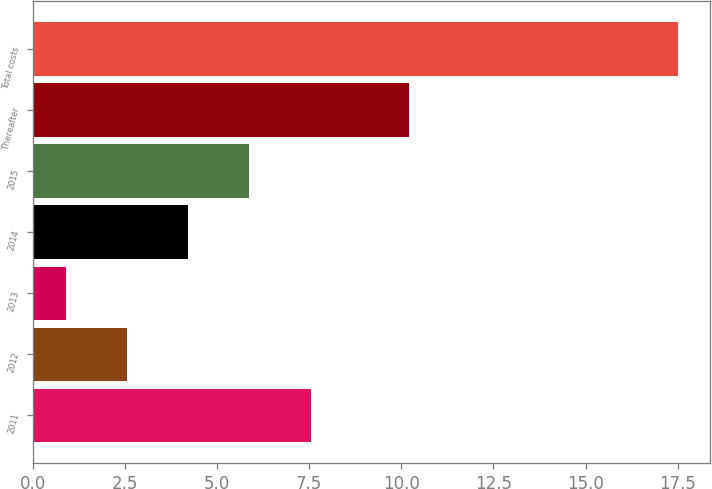<chart> <loc_0><loc_0><loc_500><loc_500><bar_chart><fcel>2011<fcel>2012<fcel>2013<fcel>2014<fcel>2015<fcel>Thereafter<fcel>Total costs<nl><fcel>7.54<fcel>2.56<fcel>0.9<fcel>4.22<fcel>5.88<fcel>10.2<fcel>17.5<nl></chart> 